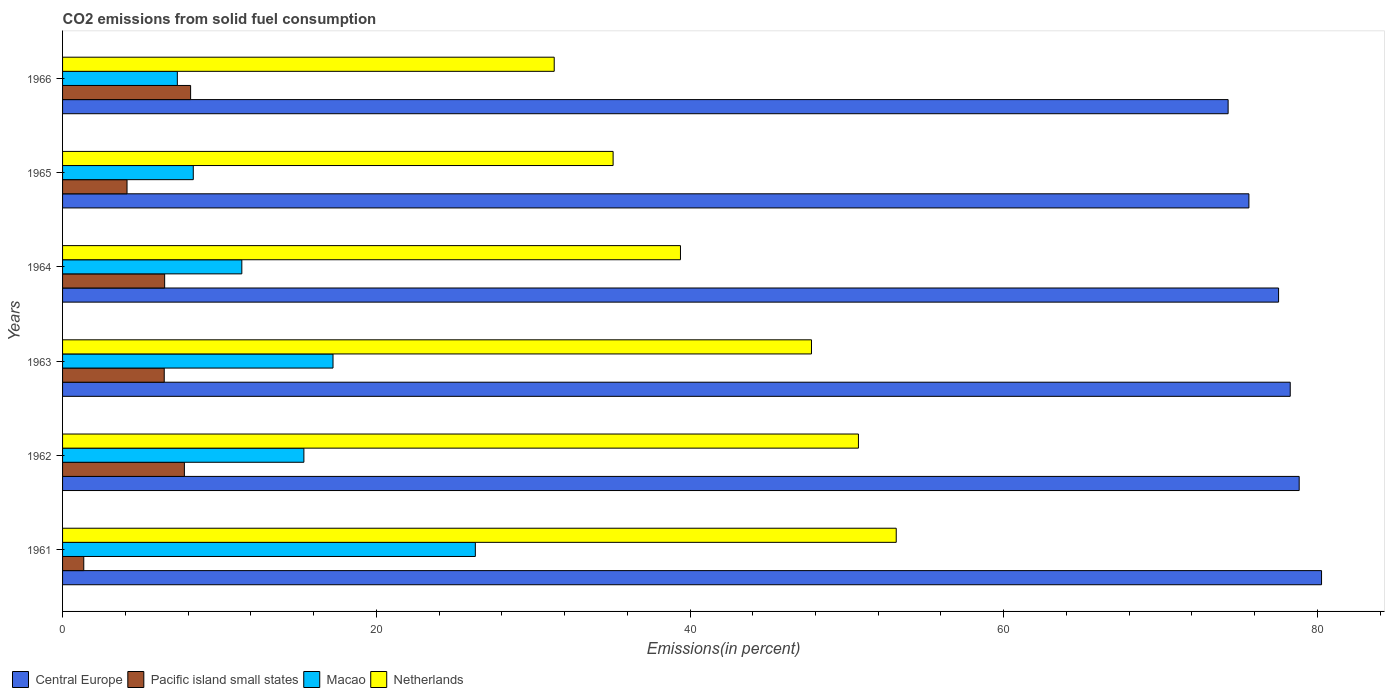How many groups of bars are there?
Make the answer very short. 6. How many bars are there on the 5th tick from the top?
Your response must be concise. 4. What is the label of the 2nd group of bars from the top?
Give a very brief answer. 1965. In how many cases, is the number of bars for a given year not equal to the number of legend labels?
Give a very brief answer. 0. What is the total CO2 emitted in Macao in 1966?
Give a very brief answer. 7.32. Across all years, what is the maximum total CO2 emitted in Macao?
Provide a succinct answer. 26.32. Across all years, what is the minimum total CO2 emitted in Netherlands?
Offer a terse response. 31.34. In which year was the total CO2 emitted in Pacific island small states maximum?
Give a very brief answer. 1966. What is the total total CO2 emitted in Central Europe in the graph?
Give a very brief answer. 464.83. What is the difference between the total CO2 emitted in Netherlands in 1961 and that in 1964?
Ensure brevity in your answer.  13.76. What is the difference between the total CO2 emitted in Netherlands in 1964 and the total CO2 emitted in Macao in 1966?
Your response must be concise. 32.08. What is the average total CO2 emitted in Macao per year?
Provide a succinct answer. 14.34. In the year 1965, what is the difference between the total CO2 emitted in Central Europe and total CO2 emitted in Netherlands?
Offer a very short reply. 40.53. In how many years, is the total CO2 emitted in Central Europe greater than 40 %?
Make the answer very short. 6. What is the ratio of the total CO2 emitted in Macao in 1962 to that in 1963?
Ensure brevity in your answer.  0.89. What is the difference between the highest and the second highest total CO2 emitted in Netherlands?
Provide a short and direct response. 2.41. What is the difference between the highest and the lowest total CO2 emitted in Macao?
Your response must be concise. 19. In how many years, is the total CO2 emitted in Netherlands greater than the average total CO2 emitted in Netherlands taken over all years?
Your answer should be very brief. 3. Is the sum of the total CO2 emitted in Central Europe in 1962 and 1963 greater than the maximum total CO2 emitted in Macao across all years?
Your answer should be very brief. Yes. Is it the case that in every year, the sum of the total CO2 emitted in Netherlands and total CO2 emitted in Central Europe is greater than the sum of total CO2 emitted in Pacific island small states and total CO2 emitted in Macao?
Offer a terse response. Yes. What does the 2nd bar from the top in 1962 represents?
Provide a short and direct response. Macao. Are all the bars in the graph horizontal?
Your response must be concise. Yes. How many years are there in the graph?
Keep it short and to the point. 6. What is the difference between two consecutive major ticks on the X-axis?
Your answer should be very brief. 20. Are the values on the major ticks of X-axis written in scientific E-notation?
Your answer should be very brief. No. What is the title of the graph?
Provide a succinct answer. CO2 emissions from solid fuel consumption. What is the label or title of the X-axis?
Offer a very short reply. Emissions(in percent). What is the Emissions(in percent) in Central Europe in 1961?
Give a very brief answer. 80.26. What is the Emissions(in percent) in Pacific island small states in 1961?
Make the answer very short. 1.35. What is the Emissions(in percent) of Macao in 1961?
Your answer should be very brief. 26.32. What is the Emissions(in percent) of Netherlands in 1961?
Your answer should be compact. 53.15. What is the Emissions(in percent) of Central Europe in 1962?
Provide a succinct answer. 78.84. What is the Emissions(in percent) of Pacific island small states in 1962?
Give a very brief answer. 7.77. What is the Emissions(in percent) of Macao in 1962?
Your response must be concise. 15.38. What is the Emissions(in percent) in Netherlands in 1962?
Your answer should be very brief. 50.74. What is the Emissions(in percent) of Central Europe in 1963?
Give a very brief answer. 78.27. What is the Emissions(in percent) in Pacific island small states in 1963?
Provide a short and direct response. 6.48. What is the Emissions(in percent) of Macao in 1963?
Ensure brevity in your answer.  17.24. What is the Emissions(in percent) in Netherlands in 1963?
Give a very brief answer. 47.74. What is the Emissions(in percent) in Central Europe in 1964?
Make the answer very short. 77.52. What is the Emissions(in percent) of Pacific island small states in 1964?
Your response must be concise. 6.51. What is the Emissions(in percent) in Macao in 1964?
Your answer should be very brief. 11.43. What is the Emissions(in percent) of Netherlands in 1964?
Give a very brief answer. 39.39. What is the Emissions(in percent) of Central Europe in 1965?
Make the answer very short. 75.63. What is the Emissions(in percent) in Pacific island small states in 1965?
Offer a very short reply. 4.11. What is the Emissions(in percent) of Macao in 1965?
Keep it short and to the point. 8.33. What is the Emissions(in percent) in Netherlands in 1965?
Offer a very short reply. 35.1. What is the Emissions(in percent) of Central Europe in 1966?
Offer a terse response. 74.31. What is the Emissions(in percent) of Pacific island small states in 1966?
Keep it short and to the point. 8.16. What is the Emissions(in percent) in Macao in 1966?
Your answer should be very brief. 7.32. What is the Emissions(in percent) of Netherlands in 1966?
Your answer should be compact. 31.34. Across all years, what is the maximum Emissions(in percent) in Central Europe?
Offer a terse response. 80.26. Across all years, what is the maximum Emissions(in percent) of Pacific island small states?
Your response must be concise. 8.16. Across all years, what is the maximum Emissions(in percent) in Macao?
Provide a succinct answer. 26.32. Across all years, what is the maximum Emissions(in percent) of Netherlands?
Ensure brevity in your answer.  53.15. Across all years, what is the minimum Emissions(in percent) of Central Europe?
Your answer should be very brief. 74.31. Across all years, what is the minimum Emissions(in percent) in Pacific island small states?
Offer a terse response. 1.35. Across all years, what is the minimum Emissions(in percent) of Macao?
Your answer should be compact. 7.32. Across all years, what is the minimum Emissions(in percent) of Netherlands?
Ensure brevity in your answer.  31.34. What is the total Emissions(in percent) of Central Europe in the graph?
Your response must be concise. 464.83. What is the total Emissions(in percent) of Pacific island small states in the graph?
Make the answer very short. 34.38. What is the total Emissions(in percent) in Macao in the graph?
Your response must be concise. 86.02. What is the total Emissions(in percent) of Netherlands in the graph?
Keep it short and to the point. 257.47. What is the difference between the Emissions(in percent) of Central Europe in 1961 and that in 1962?
Your response must be concise. 1.43. What is the difference between the Emissions(in percent) of Pacific island small states in 1961 and that in 1962?
Your answer should be very brief. -6.42. What is the difference between the Emissions(in percent) of Macao in 1961 and that in 1962?
Give a very brief answer. 10.93. What is the difference between the Emissions(in percent) of Netherlands in 1961 and that in 1962?
Offer a terse response. 2.41. What is the difference between the Emissions(in percent) of Central Europe in 1961 and that in 1963?
Keep it short and to the point. 2. What is the difference between the Emissions(in percent) in Pacific island small states in 1961 and that in 1963?
Your answer should be very brief. -5.13. What is the difference between the Emissions(in percent) of Macao in 1961 and that in 1963?
Provide a short and direct response. 9.07. What is the difference between the Emissions(in percent) in Netherlands in 1961 and that in 1963?
Your response must be concise. 5.4. What is the difference between the Emissions(in percent) of Central Europe in 1961 and that in 1964?
Ensure brevity in your answer.  2.74. What is the difference between the Emissions(in percent) of Pacific island small states in 1961 and that in 1964?
Provide a succinct answer. -5.16. What is the difference between the Emissions(in percent) of Macao in 1961 and that in 1964?
Give a very brief answer. 14.89. What is the difference between the Emissions(in percent) of Netherlands in 1961 and that in 1964?
Offer a very short reply. 13.76. What is the difference between the Emissions(in percent) in Central Europe in 1961 and that in 1965?
Offer a very short reply. 4.63. What is the difference between the Emissions(in percent) in Pacific island small states in 1961 and that in 1965?
Your response must be concise. -2.76. What is the difference between the Emissions(in percent) in Macao in 1961 and that in 1965?
Your answer should be very brief. 17.98. What is the difference between the Emissions(in percent) in Netherlands in 1961 and that in 1965?
Your answer should be very brief. 18.05. What is the difference between the Emissions(in percent) of Central Europe in 1961 and that in 1966?
Your answer should be compact. 5.96. What is the difference between the Emissions(in percent) in Pacific island small states in 1961 and that in 1966?
Give a very brief answer. -6.81. What is the difference between the Emissions(in percent) of Macao in 1961 and that in 1966?
Provide a short and direct response. 19. What is the difference between the Emissions(in percent) of Netherlands in 1961 and that in 1966?
Give a very brief answer. 21.8. What is the difference between the Emissions(in percent) of Central Europe in 1962 and that in 1963?
Keep it short and to the point. 0.57. What is the difference between the Emissions(in percent) in Pacific island small states in 1962 and that in 1963?
Ensure brevity in your answer.  1.29. What is the difference between the Emissions(in percent) of Macao in 1962 and that in 1963?
Your response must be concise. -1.86. What is the difference between the Emissions(in percent) in Netherlands in 1962 and that in 1963?
Provide a succinct answer. 2.99. What is the difference between the Emissions(in percent) in Central Europe in 1962 and that in 1964?
Your answer should be very brief. 1.31. What is the difference between the Emissions(in percent) in Pacific island small states in 1962 and that in 1964?
Keep it short and to the point. 1.26. What is the difference between the Emissions(in percent) in Macao in 1962 and that in 1964?
Your answer should be compact. 3.96. What is the difference between the Emissions(in percent) of Netherlands in 1962 and that in 1964?
Keep it short and to the point. 11.35. What is the difference between the Emissions(in percent) of Central Europe in 1962 and that in 1965?
Your response must be concise. 3.21. What is the difference between the Emissions(in percent) of Pacific island small states in 1962 and that in 1965?
Your answer should be compact. 3.66. What is the difference between the Emissions(in percent) in Macao in 1962 and that in 1965?
Your answer should be compact. 7.05. What is the difference between the Emissions(in percent) in Netherlands in 1962 and that in 1965?
Give a very brief answer. 15.64. What is the difference between the Emissions(in percent) in Central Europe in 1962 and that in 1966?
Offer a terse response. 4.53. What is the difference between the Emissions(in percent) of Pacific island small states in 1962 and that in 1966?
Ensure brevity in your answer.  -0.4. What is the difference between the Emissions(in percent) in Macao in 1962 and that in 1966?
Keep it short and to the point. 8.07. What is the difference between the Emissions(in percent) in Netherlands in 1962 and that in 1966?
Your answer should be compact. 19.4. What is the difference between the Emissions(in percent) in Central Europe in 1963 and that in 1964?
Your response must be concise. 0.74. What is the difference between the Emissions(in percent) of Pacific island small states in 1963 and that in 1964?
Make the answer very short. -0.03. What is the difference between the Emissions(in percent) in Macao in 1963 and that in 1964?
Ensure brevity in your answer.  5.81. What is the difference between the Emissions(in percent) in Netherlands in 1963 and that in 1964?
Keep it short and to the point. 8.35. What is the difference between the Emissions(in percent) of Central Europe in 1963 and that in 1965?
Offer a very short reply. 2.64. What is the difference between the Emissions(in percent) of Pacific island small states in 1963 and that in 1965?
Your response must be concise. 2.37. What is the difference between the Emissions(in percent) in Macao in 1963 and that in 1965?
Give a very brief answer. 8.91. What is the difference between the Emissions(in percent) of Netherlands in 1963 and that in 1965?
Ensure brevity in your answer.  12.65. What is the difference between the Emissions(in percent) in Central Europe in 1963 and that in 1966?
Your answer should be very brief. 3.96. What is the difference between the Emissions(in percent) of Pacific island small states in 1963 and that in 1966?
Give a very brief answer. -1.68. What is the difference between the Emissions(in percent) in Macao in 1963 and that in 1966?
Your answer should be compact. 9.92. What is the difference between the Emissions(in percent) of Netherlands in 1963 and that in 1966?
Provide a succinct answer. 16.4. What is the difference between the Emissions(in percent) in Central Europe in 1964 and that in 1965?
Offer a terse response. 1.89. What is the difference between the Emissions(in percent) in Pacific island small states in 1964 and that in 1965?
Keep it short and to the point. 2.4. What is the difference between the Emissions(in percent) in Macao in 1964 and that in 1965?
Your answer should be compact. 3.1. What is the difference between the Emissions(in percent) in Netherlands in 1964 and that in 1965?
Your answer should be very brief. 4.29. What is the difference between the Emissions(in percent) of Central Europe in 1964 and that in 1966?
Provide a succinct answer. 3.22. What is the difference between the Emissions(in percent) of Pacific island small states in 1964 and that in 1966?
Your answer should be compact. -1.65. What is the difference between the Emissions(in percent) of Macao in 1964 and that in 1966?
Your answer should be very brief. 4.11. What is the difference between the Emissions(in percent) of Netherlands in 1964 and that in 1966?
Give a very brief answer. 8.05. What is the difference between the Emissions(in percent) in Central Europe in 1965 and that in 1966?
Provide a succinct answer. 1.32. What is the difference between the Emissions(in percent) of Pacific island small states in 1965 and that in 1966?
Your response must be concise. -4.05. What is the difference between the Emissions(in percent) in Macao in 1965 and that in 1966?
Your answer should be very brief. 1.02. What is the difference between the Emissions(in percent) of Netherlands in 1965 and that in 1966?
Offer a terse response. 3.75. What is the difference between the Emissions(in percent) in Central Europe in 1961 and the Emissions(in percent) in Pacific island small states in 1962?
Ensure brevity in your answer.  72.5. What is the difference between the Emissions(in percent) of Central Europe in 1961 and the Emissions(in percent) of Macao in 1962?
Offer a very short reply. 64.88. What is the difference between the Emissions(in percent) in Central Europe in 1961 and the Emissions(in percent) in Netherlands in 1962?
Provide a succinct answer. 29.52. What is the difference between the Emissions(in percent) in Pacific island small states in 1961 and the Emissions(in percent) in Macao in 1962?
Your answer should be very brief. -14.03. What is the difference between the Emissions(in percent) of Pacific island small states in 1961 and the Emissions(in percent) of Netherlands in 1962?
Ensure brevity in your answer.  -49.39. What is the difference between the Emissions(in percent) of Macao in 1961 and the Emissions(in percent) of Netherlands in 1962?
Offer a terse response. -24.42. What is the difference between the Emissions(in percent) in Central Europe in 1961 and the Emissions(in percent) in Pacific island small states in 1963?
Your answer should be very brief. 73.78. What is the difference between the Emissions(in percent) of Central Europe in 1961 and the Emissions(in percent) of Macao in 1963?
Your response must be concise. 63.02. What is the difference between the Emissions(in percent) in Central Europe in 1961 and the Emissions(in percent) in Netherlands in 1963?
Your answer should be compact. 32.52. What is the difference between the Emissions(in percent) of Pacific island small states in 1961 and the Emissions(in percent) of Macao in 1963?
Provide a succinct answer. -15.89. What is the difference between the Emissions(in percent) of Pacific island small states in 1961 and the Emissions(in percent) of Netherlands in 1963?
Your response must be concise. -46.39. What is the difference between the Emissions(in percent) of Macao in 1961 and the Emissions(in percent) of Netherlands in 1963?
Keep it short and to the point. -21.43. What is the difference between the Emissions(in percent) of Central Europe in 1961 and the Emissions(in percent) of Pacific island small states in 1964?
Offer a terse response. 73.75. What is the difference between the Emissions(in percent) of Central Europe in 1961 and the Emissions(in percent) of Macao in 1964?
Give a very brief answer. 68.83. What is the difference between the Emissions(in percent) of Central Europe in 1961 and the Emissions(in percent) of Netherlands in 1964?
Make the answer very short. 40.87. What is the difference between the Emissions(in percent) of Pacific island small states in 1961 and the Emissions(in percent) of Macao in 1964?
Offer a very short reply. -10.08. What is the difference between the Emissions(in percent) of Pacific island small states in 1961 and the Emissions(in percent) of Netherlands in 1964?
Offer a terse response. -38.04. What is the difference between the Emissions(in percent) of Macao in 1961 and the Emissions(in percent) of Netherlands in 1964?
Your response must be concise. -13.08. What is the difference between the Emissions(in percent) in Central Europe in 1961 and the Emissions(in percent) in Pacific island small states in 1965?
Ensure brevity in your answer.  76.15. What is the difference between the Emissions(in percent) in Central Europe in 1961 and the Emissions(in percent) in Macao in 1965?
Make the answer very short. 71.93. What is the difference between the Emissions(in percent) in Central Europe in 1961 and the Emissions(in percent) in Netherlands in 1965?
Keep it short and to the point. 45.16. What is the difference between the Emissions(in percent) in Pacific island small states in 1961 and the Emissions(in percent) in Macao in 1965?
Provide a succinct answer. -6.98. What is the difference between the Emissions(in percent) of Pacific island small states in 1961 and the Emissions(in percent) of Netherlands in 1965?
Ensure brevity in your answer.  -33.75. What is the difference between the Emissions(in percent) of Macao in 1961 and the Emissions(in percent) of Netherlands in 1965?
Your answer should be very brief. -8.78. What is the difference between the Emissions(in percent) in Central Europe in 1961 and the Emissions(in percent) in Pacific island small states in 1966?
Your response must be concise. 72.1. What is the difference between the Emissions(in percent) of Central Europe in 1961 and the Emissions(in percent) of Macao in 1966?
Offer a very short reply. 72.95. What is the difference between the Emissions(in percent) in Central Europe in 1961 and the Emissions(in percent) in Netherlands in 1966?
Your response must be concise. 48.92. What is the difference between the Emissions(in percent) in Pacific island small states in 1961 and the Emissions(in percent) in Macao in 1966?
Provide a short and direct response. -5.97. What is the difference between the Emissions(in percent) in Pacific island small states in 1961 and the Emissions(in percent) in Netherlands in 1966?
Keep it short and to the point. -29.99. What is the difference between the Emissions(in percent) of Macao in 1961 and the Emissions(in percent) of Netherlands in 1966?
Ensure brevity in your answer.  -5.03. What is the difference between the Emissions(in percent) in Central Europe in 1962 and the Emissions(in percent) in Pacific island small states in 1963?
Your response must be concise. 72.36. What is the difference between the Emissions(in percent) in Central Europe in 1962 and the Emissions(in percent) in Macao in 1963?
Your response must be concise. 61.6. What is the difference between the Emissions(in percent) in Central Europe in 1962 and the Emissions(in percent) in Netherlands in 1963?
Provide a short and direct response. 31.09. What is the difference between the Emissions(in percent) of Pacific island small states in 1962 and the Emissions(in percent) of Macao in 1963?
Provide a succinct answer. -9.47. What is the difference between the Emissions(in percent) in Pacific island small states in 1962 and the Emissions(in percent) in Netherlands in 1963?
Make the answer very short. -39.98. What is the difference between the Emissions(in percent) of Macao in 1962 and the Emissions(in percent) of Netherlands in 1963?
Your answer should be very brief. -32.36. What is the difference between the Emissions(in percent) in Central Europe in 1962 and the Emissions(in percent) in Pacific island small states in 1964?
Give a very brief answer. 72.33. What is the difference between the Emissions(in percent) of Central Europe in 1962 and the Emissions(in percent) of Macao in 1964?
Provide a short and direct response. 67.41. What is the difference between the Emissions(in percent) in Central Europe in 1962 and the Emissions(in percent) in Netherlands in 1964?
Your answer should be compact. 39.44. What is the difference between the Emissions(in percent) of Pacific island small states in 1962 and the Emissions(in percent) of Macao in 1964?
Provide a short and direct response. -3.66. What is the difference between the Emissions(in percent) in Pacific island small states in 1962 and the Emissions(in percent) in Netherlands in 1964?
Offer a very short reply. -31.63. What is the difference between the Emissions(in percent) in Macao in 1962 and the Emissions(in percent) in Netherlands in 1964?
Offer a very short reply. -24.01. What is the difference between the Emissions(in percent) in Central Europe in 1962 and the Emissions(in percent) in Pacific island small states in 1965?
Your answer should be compact. 74.73. What is the difference between the Emissions(in percent) of Central Europe in 1962 and the Emissions(in percent) of Macao in 1965?
Your answer should be compact. 70.5. What is the difference between the Emissions(in percent) of Central Europe in 1962 and the Emissions(in percent) of Netherlands in 1965?
Your response must be concise. 43.74. What is the difference between the Emissions(in percent) of Pacific island small states in 1962 and the Emissions(in percent) of Macao in 1965?
Offer a terse response. -0.57. What is the difference between the Emissions(in percent) of Pacific island small states in 1962 and the Emissions(in percent) of Netherlands in 1965?
Ensure brevity in your answer.  -27.33. What is the difference between the Emissions(in percent) of Macao in 1962 and the Emissions(in percent) of Netherlands in 1965?
Make the answer very short. -19.71. What is the difference between the Emissions(in percent) of Central Europe in 1962 and the Emissions(in percent) of Pacific island small states in 1966?
Your response must be concise. 70.67. What is the difference between the Emissions(in percent) of Central Europe in 1962 and the Emissions(in percent) of Macao in 1966?
Your answer should be very brief. 71.52. What is the difference between the Emissions(in percent) in Central Europe in 1962 and the Emissions(in percent) in Netherlands in 1966?
Keep it short and to the point. 47.49. What is the difference between the Emissions(in percent) of Pacific island small states in 1962 and the Emissions(in percent) of Macao in 1966?
Give a very brief answer. 0.45. What is the difference between the Emissions(in percent) in Pacific island small states in 1962 and the Emissions(in percent) in Netherlands in 1966?
Keep it short and to the point. -23.58. What is the difference between the Emissions(in percent) of Macao in 1962 and the Emissions(in percent) of Netherlands in 1966?
Your response must be concise. -15.96. What is the difference between the Emissions(in percent) in Central Europe in 1963 and the Emissions(in percent) in Pacific island small states in 1964?
Your answer should be very brief. 71.76. What is the difference between the Emissions(in percent) in Central Europe in 1963 and the Emissions(in percent) in Macao in 1964?
Your answer should be compact. 66.84. What is the difference between the Emissions(in percent) in Central Europe in 1963 and the Emissions(in percent) in Netherlands in 1964?
Give a very brief answer. 38.87. What is the difference between the Emissions(in percent) in Pacific island small states in 1963 and the Emissions(in percent) in Macao in 1964?
Provide a succinct answer. -4.95. What is the difference between the Emissions(in percent) of Pacific island small states in 1963 and the Emissions(in percent) of Netherlands in 1964?
Provide a succinct answer. -32.91. What is the difference between the Emissions(in percent) in Macao in 1963 and the Emissions(in percent) in Netherlands in 1964?
Provide a short and direct response. -22.15. What is the difference between the Emissions(in percent) of Central Europe in 1963 and the Emissions(in percent) of Pacific island small states in 1965?
Ensure brevity in your answer.  74.16. What is the difference between the Emissions(in percent) of Central Europe in 1963 and the Emissions(in percent) of Macao in 1965?
Give a very brief answer. 69.93. What is the difference between the Emissions(in percent) in Central Europe in 1963 and the Emissions(in percent) in Netherlands in 1965?
Provide a succinct answer. 43.17. What is the difference between the Emissions(in percent) of Pacific island small states in 1963 and the Emissions(in percent) of Macao in 1965?
Your answer should be compact. -1.85. What is the difference between the Emissions(in percent) of Pacific island small states in 1963 and the Emissions(in percent) of Netherlands in 1965?
Keep it short and to the point. -28.62. What is the difference between the Emissions(in percent) of Macao in 1963 and the Emissions(in percent) of Netherlands in 1965?
Give a very brief answer. -17.86. What is the difference between the Emissions(in percent) in Central Europe in 1963 and the Emissions(in percent) in Pacific island small states in 1966?
Provide a succinct answer. 70.1. What is the difference between the Emissions(in percent) in Central Europe in 1963 and the Emissions(in percent) in Macao in 1966?
Make the answer very short. 70.95. What is the difference between the Emissions(in percent) of Central Europe in 1963 and the Emissions(in percent) of Netherlands in 1966?
Give a very brief answer. 46.92. What is the difference between the Emissions(in percent) of Pacific island small states in 1963 and the Emissions(in percent) of Macao in 1966?
Ensure brevity in your answer.  -0.84. What is the difference between the Emissions(in percent) of Pacific island small states in 1963 and the Emissions(in percent) of Netherlands in 1966?
Your answer should be compact. -24.86. What is the difference between the Emissions(in percent) in Macao in 1963 and the Emissions(in percent) in Netherlands in 1966?
Your answer should be compact. -14.1. What is the difference between the Emissions(in percent) of Central Europe in 1964 and the Emissions(in percent) of Pacific island small states in 1965?
Your response must be concise. 73.41. What is the difference between the Emissions(in percent) of Central Europe in 1964 and the Emissions(in percent) of Macao in 1965?
Make the answer very short. 69.19. What is the difference between the Emissions(in percent) in Central Europe in 1964 and the Emissions(in percent) in Netherlands in 1965?
Offer a terse response. 42.43. What is the difference between the Emissions(in percent) in Pacific island small states in 1964 and the Emissions(in percent) in Macao in 1965?
Give a very brief answer. -1.82. What is the difference between the Emissions(in percent) in Pacific island small states in 1964 and the Emissions(in percent) in Netherlands in 1965?
Your answer should be very brief. -28.59. What is the difference between the Emissions(in percent) in Macao in 1964 and the Emissions(in percent) in Netherlands in 1965?
Offer a very short reply. -23.67. What is the difference between the Emissions(in percent) in Central Europe in 1964 and the Emissions(in percent) in Pacific island small states in 1966?
Your answer should be compact. 69.36. What is the difference between the Emissions(in percent) in Central Europe in 1964 and the Emissions(in percent) in Macao in 1966?
Make the answer very short. 70.21. What is the difference between the Emissions(in percent) of Central Europe in 1964 and the Emissions(in percent) of Netherlands in 1966?
Provide a short and direct response. 46.18. What is the difference between the Emissions(in percent) in Pacific island small states in 1964 and the Emissions(in percent) in Macao in 1966?
Offer a terse response. -0.81. What is the difference between the Emissions(in percent) in Pacific island small states in 1964 and the Emissions(in percent) in Netherlands in 1966?
Your answer should be very brief. -24.84. What is the difference between the Emissions(in percent) of Macao in 1964 and the Emissions(in percent) of Netherlands in 1966?
Keep it short and to the point. -19.92. What is the difference between the Emissions(in percent) of Central Europe in 1965 and the Emissions(in percent) of Pacific island small states in 1966?
Make the answer very short. 67.47. What is the difference between the Emissions(in percent) in Central Europe in 1965 and the Emissions(in percent) in Macao in 1966?
Offer a very short reply. 68.31. What is the difference between the Emissions(in percent) in Central Europe in 1965 and the Emissions(in percent) in Netherlands in 1966?
Keep it short and to the point. 44.29. What is the difference between the Emissions(in percent) in Pacific island small states in 1965 and the Emissions(in percent) in Macao in 1966?
Make the answer very short. -3.21. What is the difference between the Emissions(in percent) of Pacific island small states in 1965 and the Emissions(in percent) of Netherlands in 1966?
Keep it short and to the point. -27.23. What is the difference between the Emissions(in percent) in Macao in 1965 and the Emissions(in percent) in Netherlands in 1966?
Your response must be concise. -23.01. What is the average Emissions(in percent) in Central Europe per year?
Provide a succinct answer. 77.47. What is the average Emissions(in percent) in Pacific island small states per year?
Your answer should be very brief. 5.73. What is the average Emissions(in percent) in Macao per year?
Provide a succinct answer. 14.34. What is the average Emissions(in percent) in Netherlands per year?
Offer a terse response. 42.91. In the year 1961, what is the difference between the Emissions(in percent) of Central Europe and Emissions(in percent) of Pacific island small states?
Offer a terse response. 78.91. In the year 1961, what is the difference between the Emissions(in percent) in Central Europe and Emissions(in percent) in Macao?
Give a very brief answer. 53.95. In the year 1961, what is the difference between the Emissions(in percent) in Central Europe and Emissions(in percent) in Netherlands?
Your answer should be very brief. 27.11. In the year 1961, what is the difference between the Emissions(in percent) in Pacific island small states and Emissions(in percent) in Macao?
Offer a very short reply. -24.96. In the year 1961, what is the difference between the Emissions(in percent) in Pacific island small states and Emissions(in percent) in Netherlands?
Your answer should be compact. -51.8. In the year 1961, what is the difference between the Emissions(in percent) in Macao and Emissions(in percent) in Netherlands?
Make the answer very short. -26.83. In the year 1962, what is the difference between the Emissions(in percent) in Central Europe and Emissions(in percent) in Pacific island small states?
Your response must be concise. 71.07. In the year 1962, what is the difference between the Emissions(in percent) in Central Europe and Emissions(in percent) in Macao?
Your response must be concise. 63.45. In the year 1962, what is the difference between the Emissions(in percent) in Central Europe and Emissions(in percent) in Netherlands?
Provide a short and direct response. 28.1. In the year 1962, what is the difference between the Emissions(in percent) of Pacific island small states and Emissions(in percent) of Macao?
Ensure brevity in your answer.  -7.62. In the year 1962, what is the difference between the Emissions(in percent) in Pacific island small states and Emissions(in percent) in Netherlands?
Keep it short and to the point. -42.97. In the year 1962, what is the difference between the Emissions(in percent) of Macao and Emissions(in percent) of Netherlands?
Provide a succinct answer. -35.35. In the year 1963, what is the difference between the Emissions(in percent) in Central Europe and Emissions(in percent) in Pacific island small states?
Provide a succinct answer. 71.79. In the year 1963, what is the difference between the Emissions(in percent) in Central Europe and Emissions(in percent) in Macao?
Keep it short and to the point. 61.03. In the year 1963, what is the difference between the Emissions(in percent) in Central Europe and Emissions(in percent) in Netherlands?
Give a very brief answer. 30.52. In the year 1963, what is the difference between the Emissions(in percent) of Pacific island small states and Emissions(in percent) of Macao?
Your answer should be compact. -10.76. In the year 1963, what is the difference between the Emissions(in percent) of Pacific island small states and Emissions(in percent) of Netherlands?
Offer a very short reply. -41.26. In the year 1963, what is the difference between the Emissions(in percent) of Macao and Emissions(in percent) of Netherlands?
Provide a short and direct response. -30.5. In the year 1964, what is the difference between the Emissions(in percent) in Central Europe and Emissions(in percent) in Pacific island small states?
Your response must be concise. 71.02. In the year 1964, what is the difference between the Emissions(in percent) in Central Europe and Emissions(in percent) in Macao?
Offer a terse response. 66.1. In the year 1964, what is the difference between the Emissions(in percent) of Central Europe and Emissions(in percent) of Netherlands?
Give a very brief answer. 38.13. In the year 1964, what is the difference between the Emissions(in percent) of Pacific island small states and Emissions(in percent) of Macao?
Your answer should be compact. -4.92. In the year 1964, what is the difference between the Emissions(in percent) of Pacific island small states and Emissions(in percent) of Netherlands?
Give a very brief answer. -32.88. In the year 1964, what is the difference between the Emissions(in percent) of Macao and Emissions(in percent) of Netherlands?
Offer a terse response. -27.96. In the year 1965, what is the difference between the Emissions(in percent) of Central Europe and Emissions(in percent) of Pacific island small states?
Provide a short and direct response. 71.52. In the year 1965, what is the difference between the Emissions(in percent) in Central Europe and Emissions(in percent) in Macao?
Your response must be concise. 67.3. In the year 1965, what is the difference between the Emissions(in percent) of Central Europe and Emissions(in percent) of Netherlands?
Ensure brevity in your answer.  40.53. In the year 1965, what is the difference between the Emissions(in percent) of Pacific island small states and Emissions(in percent) of Macao?
Your answer should be very brief. -4.22. In the year 1965, what is the difference between the Emissions(in percent) of Pacific island small states and Emissions(in percent) of Netherlands?
Offer a very short reply. -30.99. In the year 1965, what is the difference between the Emissions(in percent) in Macao and Emissions(in percent) in Netherlands?
Provide a succinct answer. -26.76. In the year 1966, what is the difference between the Emissions(in percent) in Central Europe and Emissions(in percent) in Pacific island small states?
Give a very brief answer. 66.14. In the year 1966, what is the difference between the Emissions(in percent) of Central Europe and Emissions(in percent) of Macao?
Your response must be concise. 66.99. In the year 1966, what is the difference between the Emissions(in percent) in Central Europe and Emissions(in percent) in Netherlands?
Offer a very short reply. 42.96. In the year 1966, what is the difference between the Emissions(in percent) in Pacific island small states and Emissions(in percent) in Macao?
Provide a short and direct response. 0.85. In the year 1966, what is the difference between the Emissions(in percent) in Pacific island small states and Emissions(in percent) in Netherlands?
Ensure brevity in your answer.  -23.18. In the year 1966, what is the difference between the Emissions(in percent) in Macao and Emissions(in percent) in Netherlands?
Offer a terse response. -24.03. What is the ratio of the Emissions(in percent) in Central Europe in 1961 to that in 1962?
Give a very brief answer. 1.02. What is the ratio of the Emissions(in percent) in Pacific island small states in 1961 to that in 1962?
Ensure brevity in your answer.  0.17. What is the ratio of the Emissions(in percent) in Macao in 1961 to that in 1962?
Offer a very short reply. 1.71. What is the ratio of the Emissions(in percent) in Netherlands in 1961 to that in 1962?
Make the answer very short. 1.05. What is the ratio of the Emissions(in percent) in Central Europe in 1961 to that in 1963?
Offer a terse response. 1.03. What is the ratio of the Emissions(in percent) of Pacific island small states in 1961 to that in 1963?
Your answer should be very brief. 0.21. What is the ratio of the Emissions(in percent) of Macao in 1961 to that in 1963?
Keep it short and to the point. 1.53. What is the ratio of the Emissions(in percent) of Netherlands in 1961 to that in 1963?
Your answer should be compact. 1.11. What is the ratio of the Emissions(in percent) of Central Europe in 1961 to that in 1964?
Your response must be concise. 1.04. What is the ratio of the Emissions(in percent) of Pacific island small states in 1961 to that in 1964?
Your answer should be compact. 0.21. What is the ratio of the Emissions(in percent) of Macao in 1961 to that in 1964?
Provide a succinct answer. 2.3. What is the ratio of the Emissions(in percent) of Netherlands in 1961 to that in 1964?
Your answer should be very brief. 1.35. What is the ratio of the Emissions(in percent) of Central Europe in 1961 to that in 1965?
Ensure brevity in your answer.  1.06. What is the ratio of the Emissions(in percent) in Pacific island small states in 1961 to that in 1965?
Your response must be concise. 0.33. What is the ratio of the Emissions(in percent) of Macao in 1961 to that in 1965?
Provide a short and direct response. 3.16. What is the ratio of the Emissions(in percent) in Netherlands in 1961 to that in 1965?
Keep it short and to the point. 1.51. What is the ratio of the Emissions(in percent) of Central Europe in 1961 to that in 1966?
Provide a succinct answer. 1.08. What is the ratio of the Emissions(in percent) in Pacific island small states in 1961 to that in 1966?
Offer a terse response. 0.17. What is the ratio of the Emissions(in percent) of Macao in 1961 to that in 1966?
Offer a very short reply. 3.6. What is the ratio of the Emissions(in percent) in Netherlands in 1961 to that in 1966?
Your response must be concise. 1.7. What is the ratio of the Emissions(in percent) of Central Europe in 1962 to that in 1963?
Provide a succinct answer. 1.01. What is the ratio of the Emissions(in percent) in Pacific island small states in 1962 to that in 1963?
Keep it short and to the point. 1.2. What is the ratio of the Emissions(in percent) in Macao in 1962 to that in 1963?
Provide a succinct answer. 0.89. What is the ratio of the Emissions(in percent) in Netherlands in 1962 to that in 1963?
Provide a succinct answer. 1.06. What is the ratio of the Emissions(in percent) in Central Europe in 1962 to that in 1964?
Your response must be concise. 1.02. What is the ratio of the Emissions(in percent) in Pacific island small states in 1962 to that in 1964?
Provide a succinct answer. 1.19. What is the ratio of the Emissions(in percent) in Macao in 1962 to that in 1964?
Your answer should be very brief. 1.35. What is the ratio of the Emissions(in percent) in Netherlands in 1962 to that in 1964?
Your answer should be very brief. 1.29. What is the ratio of the Emissions(in percent) of Central Europe in 1962 to that in 1965?
Give a very brief answer. 1.04. What is the ratio of the Emissions(in percent) in Pacific island small states in 1962 to that in 1965?
Give a very brief answer. 1.89. What is the ratio of the Emissions(in percent) in Macao in 1962 to that in 1965?
Your answer should be compact. 1.85. What is the ratio of the Emissions(in percent) in Netherlands in 1962 to that in 1965?
Ensure brevity in your answer.  1.45. What is the ratio of the Emissions(in percent) of Central Europe in 1962 to that in 1966?
Provide a succinct answer. 1.06. What is the ratio of the Emissions(in percent) of Pacific island small states in 1962 to that in 1966?
Make the answer very short. 0.95. What is the ratio of the Emissions(in percent) of Macao in 1962 to that in 1966?
Provide a short and direct response. 2.1. What is the ratio of the Emissions(in percent) in Netherlands in 1962 to that in 1966?
Your answer should be compact. 1.62. What is the ratio of the Emissions(in percent) of Central Europe in 1963 to that in 1964?
Your answer should be compact. 1.01. What is the ratio of the Emissions(in percent) of Macao in 1963 to that in 1964?
Offer a very short reply. 1.51. What is the ratio of the Emissions(in percent) in Netherlands in 1963 to that in 1964?
Provide a succinct answer. 1.21. What is the ratio of the Emissions(in percent) of Central Europe in 1963 to that in 1965?
Offer a terse response. 1.03. What is the ratio of the Emissions(in percent) in Pacific island small states in 1963 to that in 1965?
Offer a terse response. 1.58. What is the ratio of the Emissions(in percent) in Macao in 1963 to that in 1965?
Make the answer very short. 2.07. What is the ratio of the Emissions(in percent) in Netherlands in 1963 to that in 1965?
Your answer should be compact. 1.36. What is the ratio of the Emissions(in percent) in Central Europe in 1963 to that in 1966?
Your response must be concise. 1.05. What is the ratio of the Emissions(in percent) of Pacific island small states in 1963 to that in 1966?
Your answer should be compact. 0.79. What is the ratio of the Emissions(in percent) of Macao in 1963 to that in 1966?
Give a very brief answer. 2.36. What is the ratio of the Emissions(in percent) of Netherlands in 1963 to that in 1966?
Provide a succinct answer. 1.52. What is the ratio of the Emissions(in percent) in Central Europe in 1964 to that in 1965?
Your answer should be compact. 1.02. What is the ratio of the Emissions(in percent) of Pacific island small states in 1964 to that in 1965?
Give a very brief answer. 1.58. What is the ratio of the Emissions(in percent) of Macao in 1964 to that in 1965?
Provide a succinct answer. 1.37. What is the ratio of the Emissions(in percent) in Netherlands in 1964 to that in 1965?
Your response must be concise. 1.12. What is the ratio of the Emissions(in percent) of Central Europe in 1964 to that in 1966?
Your response must be concise. 1.04. What is the ratio of the Emissions(in percent) of Pacific island small states in 1964 to that in 1966?
Offer a terse response. 0.8. What is the ratio of the Emissions(in percent) in Macao in 1964 to that in 1966?
Keep it short and to the point. 1.56. What is the ratio of the Emissions(in percent) of Netherlands in 1964 to that in 1966?
Your answer should be very brief. 1.26. What is the ratio of the Emissions(in percent) of Central Europe in 1965 to that in 1966?
Your answer should be very brief. 1.02. What is the ratio of the Emissions(in percent) of Pacific island small states in 1965 to that in 1966?
Provide a short and direct response. 0.5. What is the ratio of the Emissions(in percent) in Macao in 1965 to that in 1966?
Your answer should be very brief. 1.14. What is the ratio of the Emissions(in percent) of Netherlands in 1965 to that in 1966?
Offer a terse response. 1.12. What is the difference between the highest and the second highest Emissions(in percent) of Central Europe?
Give a very brief answer. 1.43. What is the difference between the highest and the second highest Emissions(in percent) of Pacific island small states?
Your response must be concise. 0.4. What is the difference between the highest and the second highest Emissions(in percent) of Macao?
Your answer should be compact. 9.07. What is the difference between the highest and the second highest Emissions(in percent) of Netherlands?
Keep it short and to the point. 2.41. What is the difference between the highest and the lowest Emissions(in percent) in Central Europe?
Make the answer very short. 5.96. What is the difference between the highest and the lowest Emissions(in percent) in Pacific island small states?
Your answer should be compact. 6.81. What is the difference between the highest and the lowest Emissions(in percent) of Macao?
Keep it short and to the point. 19. What is the difference between the highest and the lowest Emissions(in percent) in Netherlands?
Offer a terse response. 21.8. 